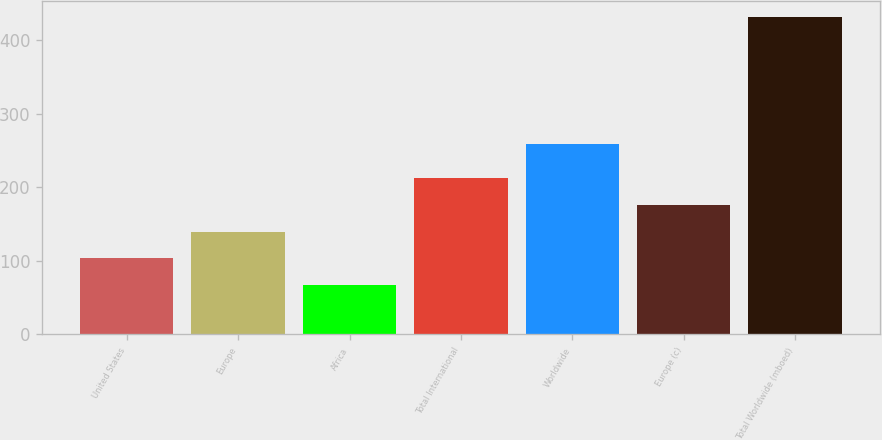<chart> <loc_0><loc_0><loc_500><loc_500><bar_chart><fcel>United States<fcel>Europe<fcel>Africa<fcel>Total International<fcel>Worldwide<fcel>Europe (c)<fcel>Total Worldwide (mboed)<nl><fcel>103.5<fcel>140<fcel>67<fcel>213<fcel>259<fcel>176.5<fcel>432<nl></chart> 